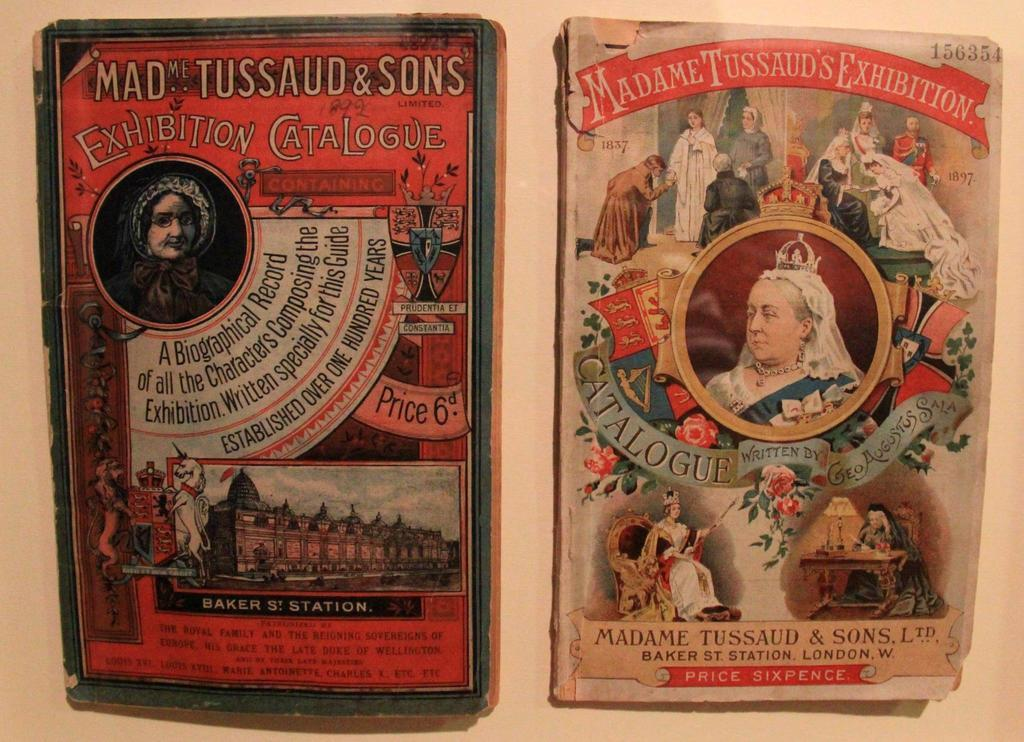What type of items are featured on the book covers in the image? The image contains book covers with various elements. Can you describe the person depicted on the book cover? Yes, there is a picture of a person on the book cover. What other objects or symbols can be seen on the book cover? A flower, a building, a shield, and a horse are depicted on the book cover. How many letters are visible on the book cover? There is no mention of letters on the book cover in the provided facts, so we cannot determine the number of letters present. 